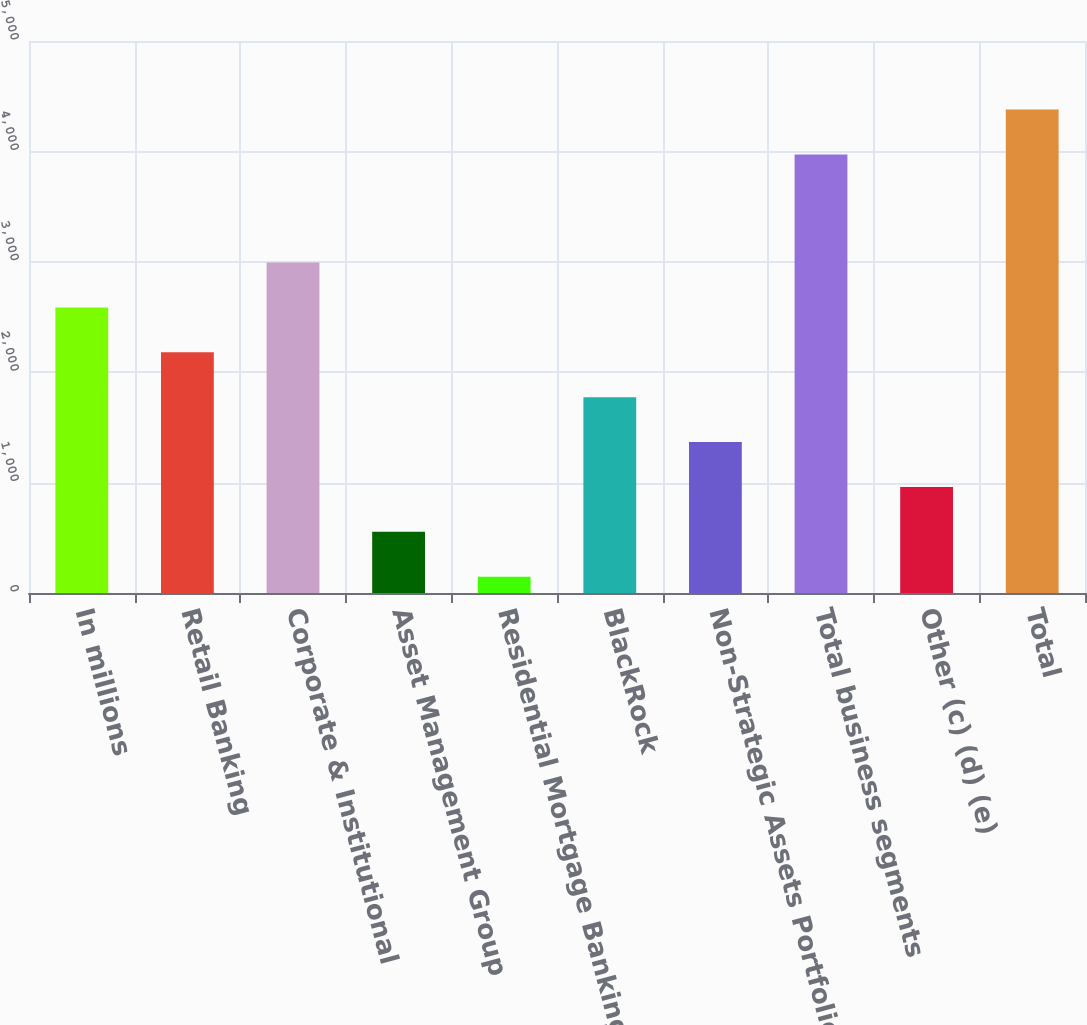Convert chart. <chart><loc_0><loc_0><loc_500><loc_500><bar_chart><fcel>In millions<fcel>Retail Banking<fcel>Corporate & Institutional<fcel>Asset Management Group<fcel>Residential Mortgage Banking<fcel>BlackRock<fcel>Non-Strategic Assets Portfolio<fcel>Total business segments<fcel>Other (c) (d) (e)<fcel>Total<nl><fcel>2586.4<fcel>2180<fcel>2992.8<fcel>554.4<fcel>148<fcel>1773.6<fcel>1367.2<fcel>3972<fcel>960.8<fcel>4378.4<nl></chart> 